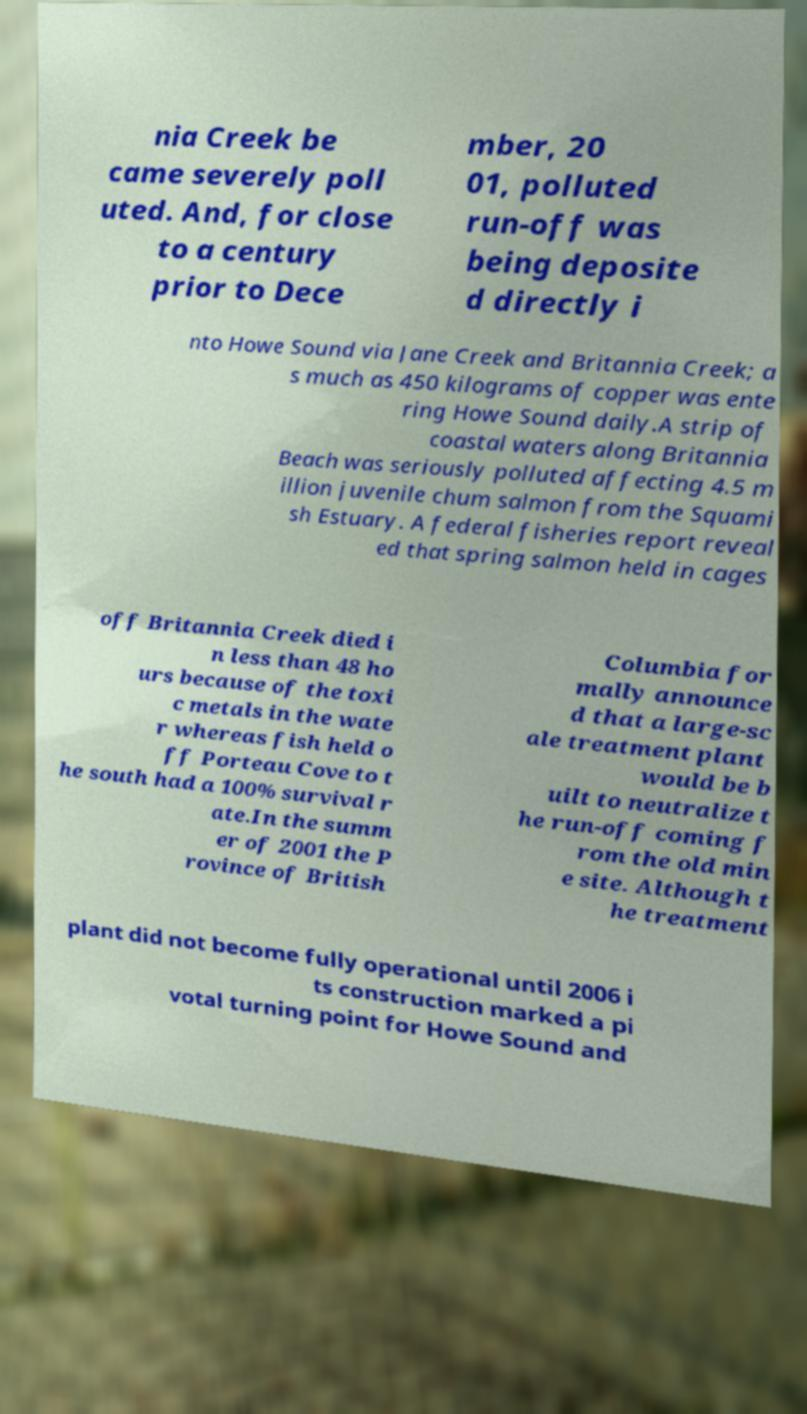Please identify and transcribe the text found in this image. nia Creek be came severely poll uted. And, for close to a century prior to Dece mber, 20 01, polluted run-off was being deposite d directly i nto Howe Sound via Jane Creek and Britannia Creek; a s much as 450 kilograms of copper was ente ring Howe Sound daily.A strip of coastal waters along Britannia Beach was seriously polluted affecting 4.5 m illion juvenile chum salmon from the Squami sh Estuary. A federal fisheries report reveal ed that spring salmon held in cages off Britannia Creek died i n less than 48 ho urs because of the toxi c metals in the wate r whereas fish held o ff Porteau Cove to t he south had a 100% survival r ate.In the summ er of 2001 the P rovince of British Columbia for mally announce d that a large-sc ale treatment plant would be b uilt to neutralize t he run-off coming f rom the old min e site. Although t he treatment plant did not become fully operational until 2006 i ts construction marked a pi votal turning point for Howe Sound and 